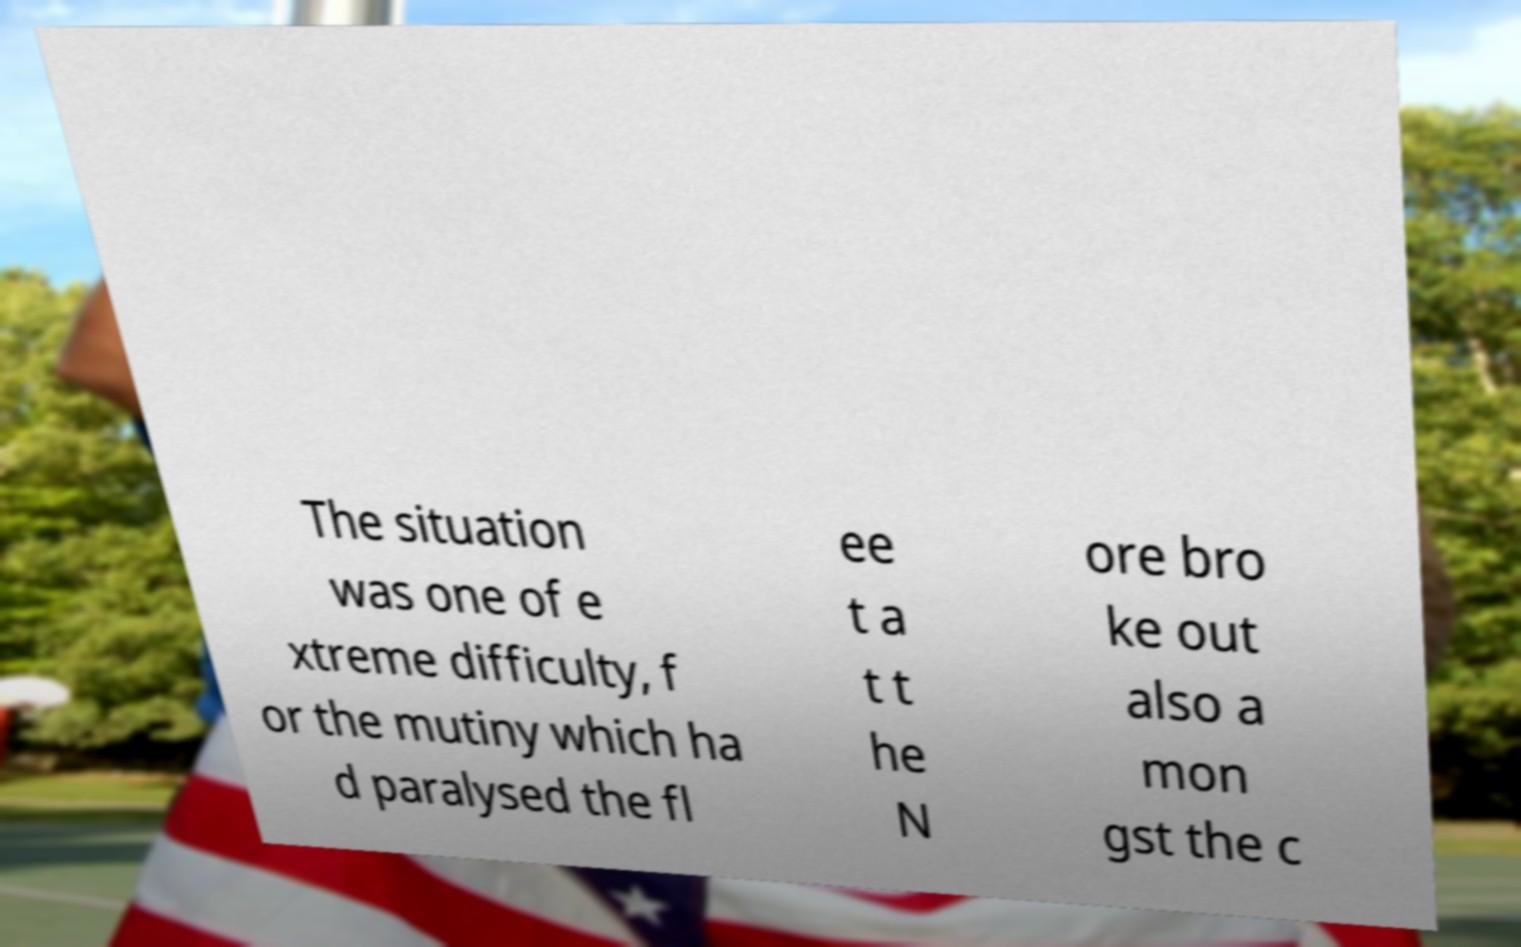I need the written content from this picture converted into text. Can you do that? The situation was one of e xtreme difficulty, f or the mutiny which ha d paralysed the fl ee t a t t he N ore bro ke out also a mon gst the c 